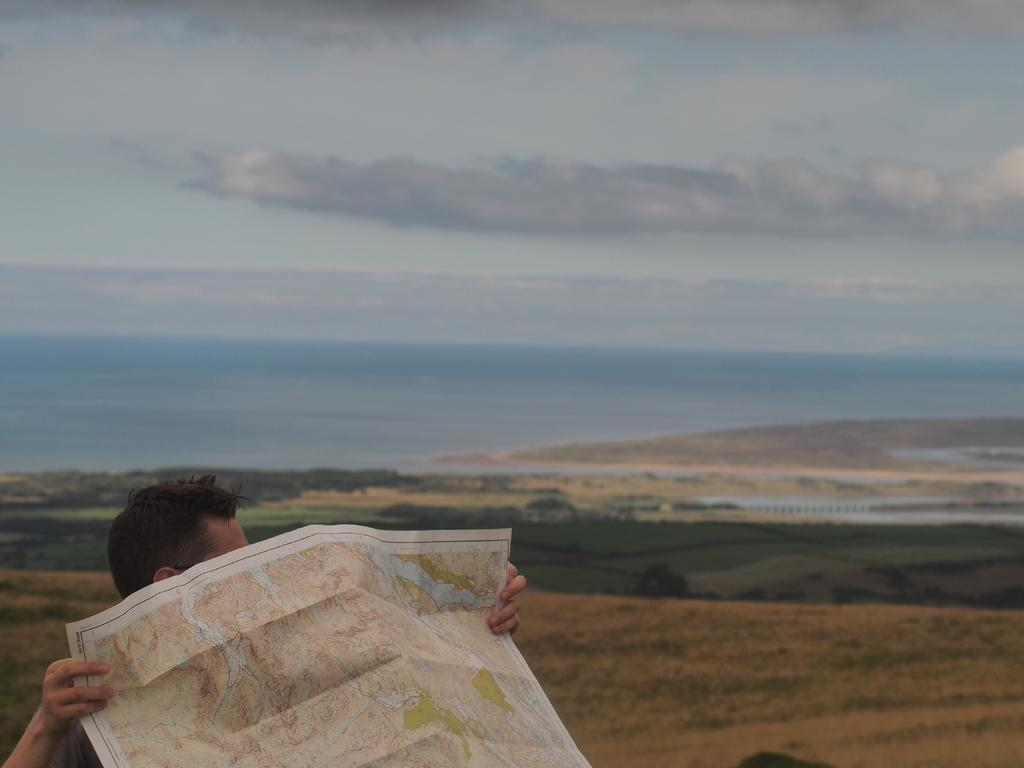What can be seen at the top of the image? The sky is visible in the image. Can you describe the person at the bottom of the image? There is a person visible at the bottom of the image, and they are holding a paper. What direction is the fog moving in the image? There is no fog present in the image. How many grapes can be seen in the person's hand in the image? There are no grapes visible in the image; the person is holding a paper. 